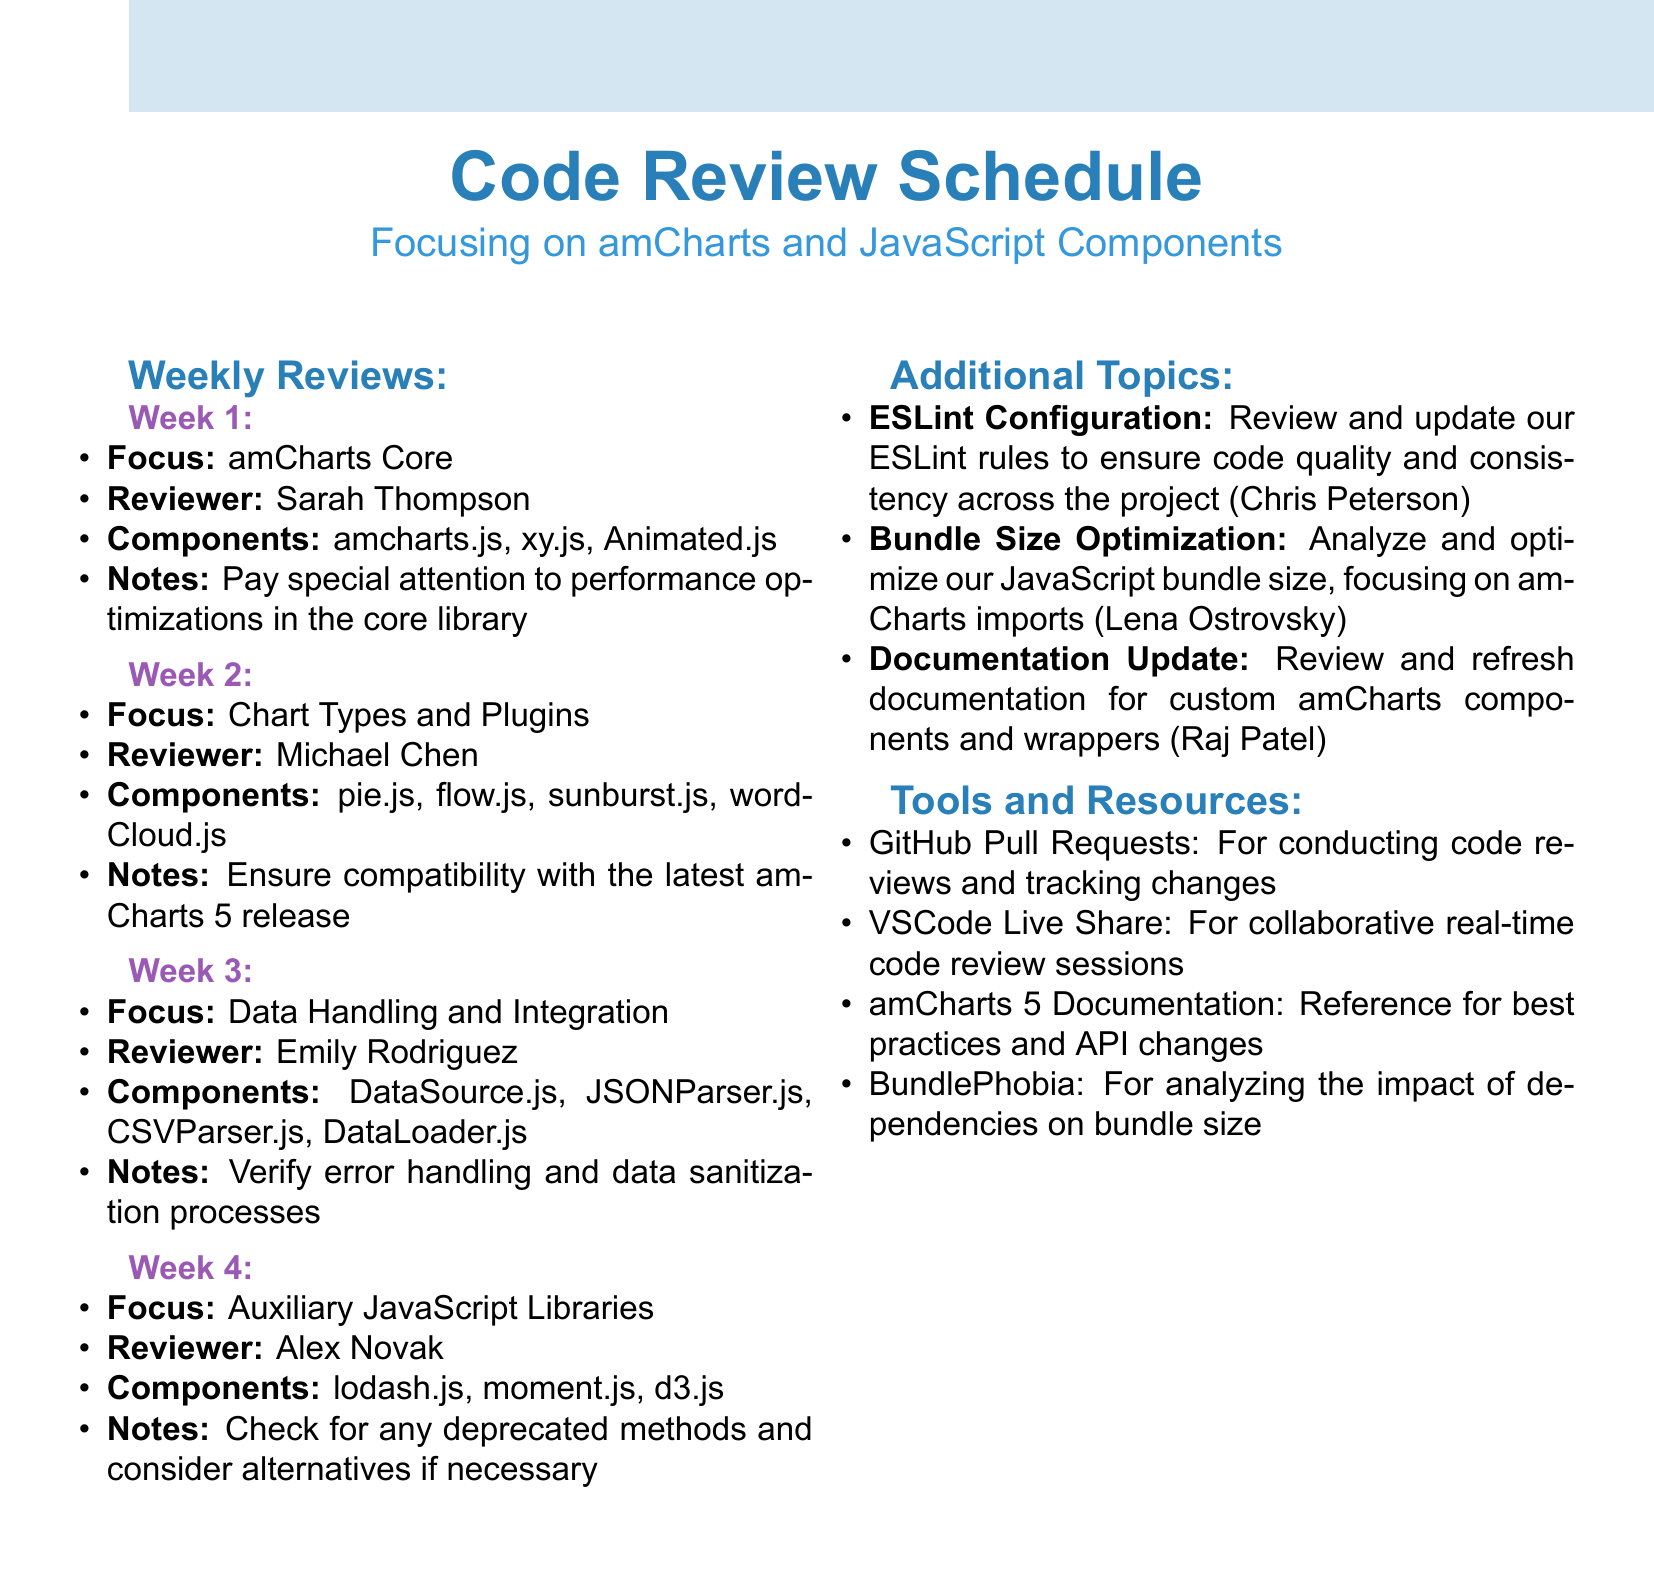what is the focus of week 1? The focus for week 1 is specified in the document under the weekly reviews section.
Answer: amCharts Core who is the reviewer for week 2? The document lists the reviewer for each week in the weekly reviews section.
Answer: Michael Chen which component is reviewed in week 3? The components for each week are detailed under the weekly reviews section.
Answer: DataSource.js what is the assigned topic for the third additional topic? The additional topics are numbered in the document, making it easy to identify each one.
Answer: Documentation Update which tool is used for collaborative real-time code review sessions? The tools and resources section provides the purpose of each tool listed.
Answer: VSCode Live Share what is the note for week 4's review? Each week has specific notes aimed at guiding the reviewers, indicated in the weekly reviews section.
Answer: Check for any deprecated methods and consider alternatives if necessary who is assigned to analyze JavaScript bundle size? The additional topics section includes the person assigned to each topic.
Answer: Lena Ostrovsky how many components are listed for week 1? The document has a specified list of components for each week, indicating the count.
Answer: 3 